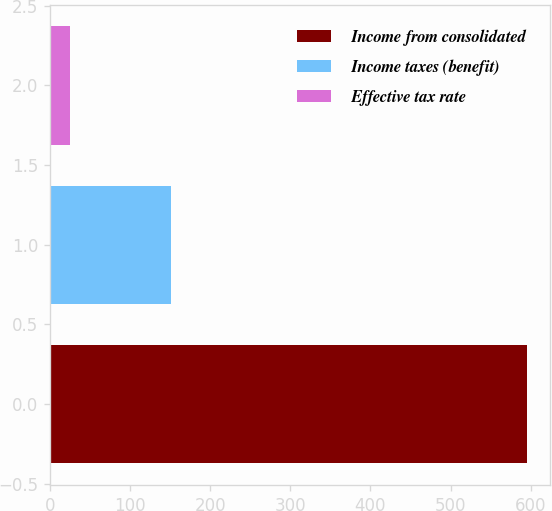<chart> <loc_0><loc_0><loc_500><loc_500><bar_chart><fcel>Income from consolidated<fcel>Income taxes (benefit)<fcel>Effective tax rate<nl><fcel>594.8<fcel>151.3<fcel>25.4<nl></chart> 